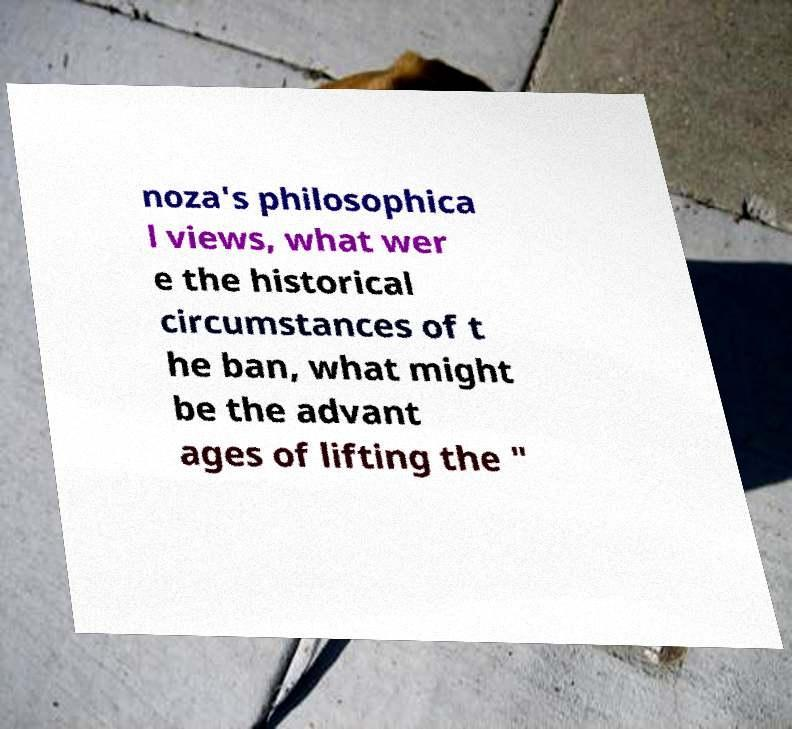I need the written content from this picture converted into text. Can you do that? noza's philosophica l views, what wer e the historical circumstances of t he ban, what might be the advant ages of lifting the " 